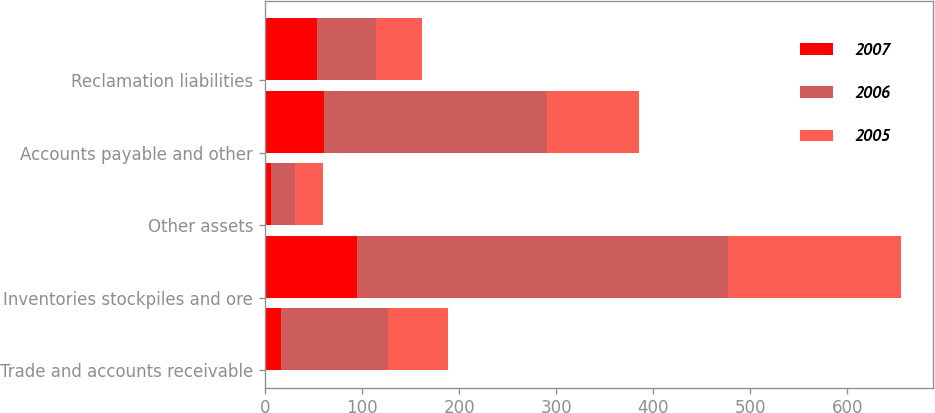Convert chart. <chart><loc_0><loc_0><loc_500><loc_500><stacked_bar_chart><ecel><fcel>Trade and accounts receivable<fcel>Inventories stockpiles and ore<fcel>Other assets<fcel>Accounts payable and other<fcel>Reclamation liabilities<nl><fcel>2007<fcel>17<fcel>95<fcel>6<fcel>61<fcel>54<nl><fcel>2006<fcel>110<fcel>382<fcel>25<fcel>230<fcel>60<nl><fcel>2005<fcel>62<fcel>178<fcel>29<fcel>94<fcel>48<nl></chart> 